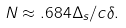Convert formula to latex. <formula><loc_0><loc_0><loc_500><loc_500>N \approx . 6 8 4 \Delta _ { s } / c \delta .</formula> 